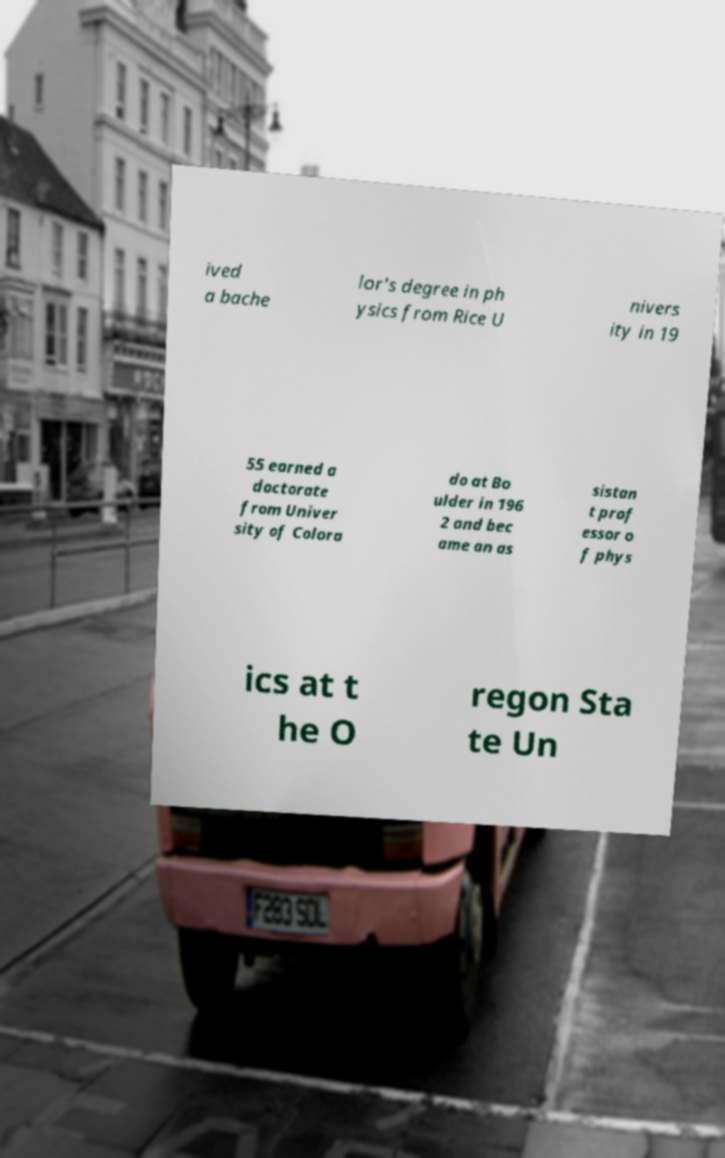I need the written content from this picture converted into text. Can you do that? ived a bache lor's degree in ph ysics from Rice U nivers ity in 19 55 earned a doctorate from Univer sity of Colora do at Bo ulder in 196 2 and bec ame an as sistan t prof essor o f phys ics at t he O regon Sta te Un 